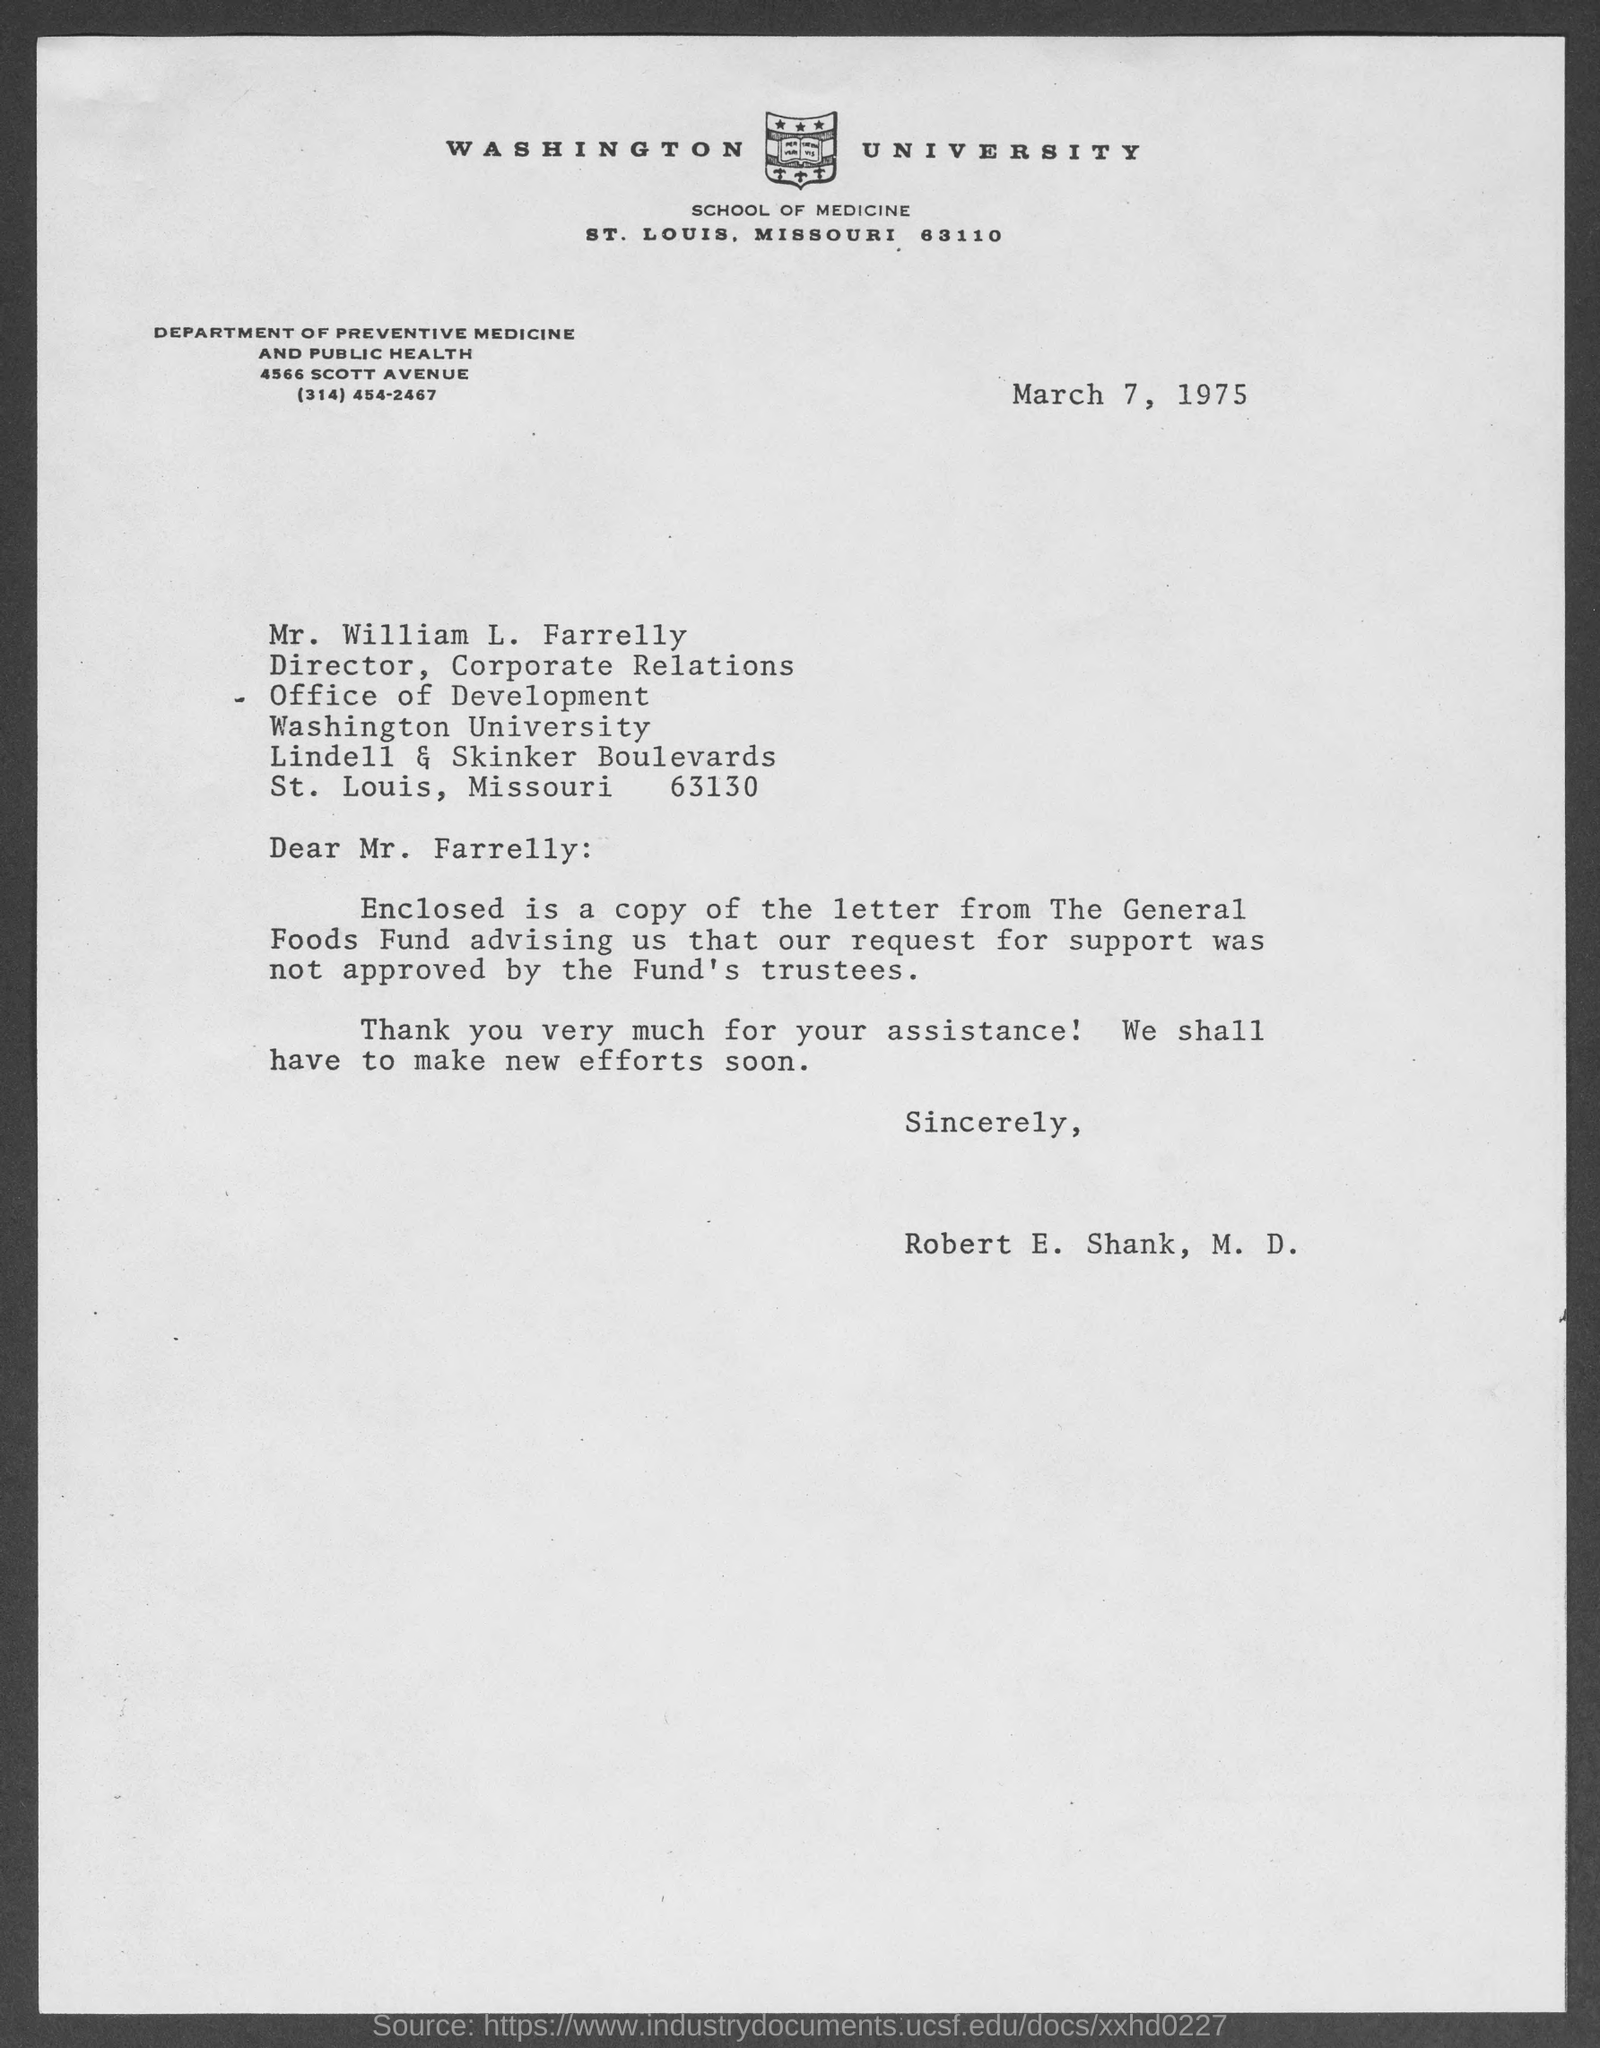When is the document dated?
Make the answer very short. March 7, 1975. To whom is the letter addressed?
Ensure brevity in your answer.  Mr. William L. Farrelly. Which Fund did not approve the request for support?
Keep it short and to the point. The General Foods Fund. Who is the sender?
Ensure brevity in your answer.  Robert E. Shank. 